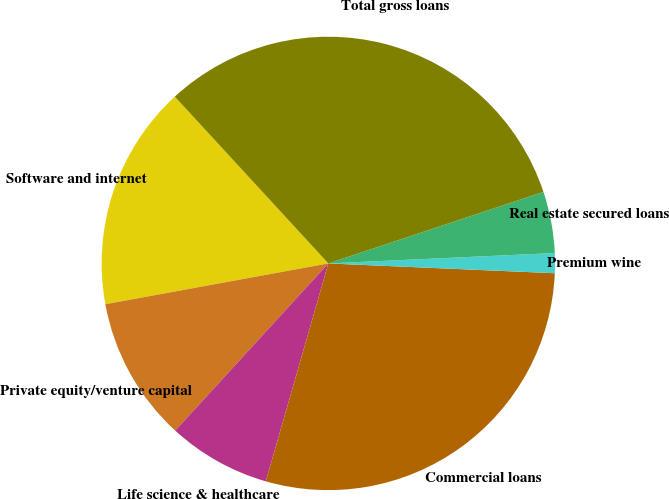<chart> <loc_0><loc_0><loc_500><loc_500><pie_chart><fcel>Software and internet<fcel>Private equity/venture capital<fcel>Life science & healthcare<fcel>Commercial loans<fcel>Premium wine<fcel>Real estate secured loans<fcel>Total gross loans<nl><fcel>16.04%<fcel>10.32%<fcel>7.35%<fcel>28.76%<fcel>1.42%<fcel>4.38%<fcel>31.73%<nl></chart> 